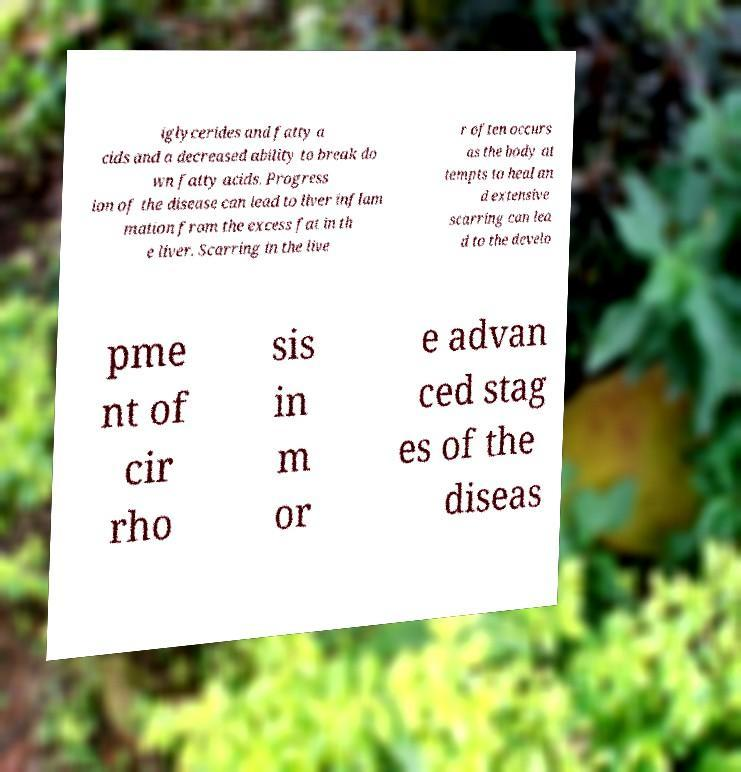Please read and relay the text visible in this image. What does it say? iglycerides and fatty a cids and a decreased ability to break do wn fatty acids. Progress ion of the disease can lead to liver inflam mation from the excess fat in th e liver. Scarring in the live r often occurs as the body at tempts to heal an d extensive scarring can lea d to the develo pme nt of cir rho sis in m or e advan ced stag es of the diseas 